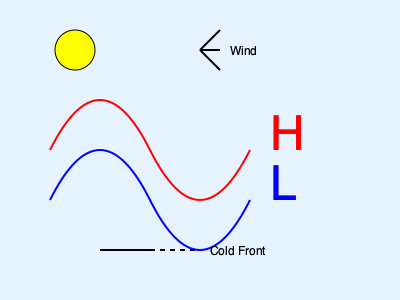Based on the meteorological map provided, what weather conditions should the aircraft carrier expect, and how might these conditions affect flight operations? 1. High and Low Pressure Systems:
   - The red line with "H" indicates a high-pressure system.
   - The blue line with "L" indicates a low-pressure system.
   - High-pressure systems generally bring fair weather, while low-pressure systems often bring unstable conditions.

2. Cold Front:
   - The black line with triangles represents a cold front.
   - Cold fronts typically bring rapid changes in weather, including precipitation and wind shifts.

3. Wind Direction:
   - The wind barb in the upper right indicates wind direction and speed.
   - Wind is moving from northwest to southeast.

4. Sun Symbol:
   - The sun symbol in the upper left suggests clear or partly cloudy conditions in that area.

5. Impact on Naval Operations:
   - The approaching cold front may bring deteriorating weather conditions.
   - Wind shift associated with the cold front could affect flight operations.
   - The high-pressure system ahead of the front may provide a window of fair weather for operations.

6. Flight Operations Considerations:
   - Increased turbulence and wind shear near the front boundary.
   - Possible need to adjust landing and takeoff patterns due to changing winds.
   - Potential for reduced visibility if the front brings precipitation or low clouds.

7. Operational Decision:
   - Plan for a possible weather window before the front arrives.
   - Prepare for changing conditions and be ready to modify or suspend flight operations as the front approaches.
Answer: Expect fair weather initially, followed by deteriorating conditions as the cold front approaches. Flight operations may be affected by changing winds and potential turbulence, requiring careful planning and possible adjustments or temporary suspension. 